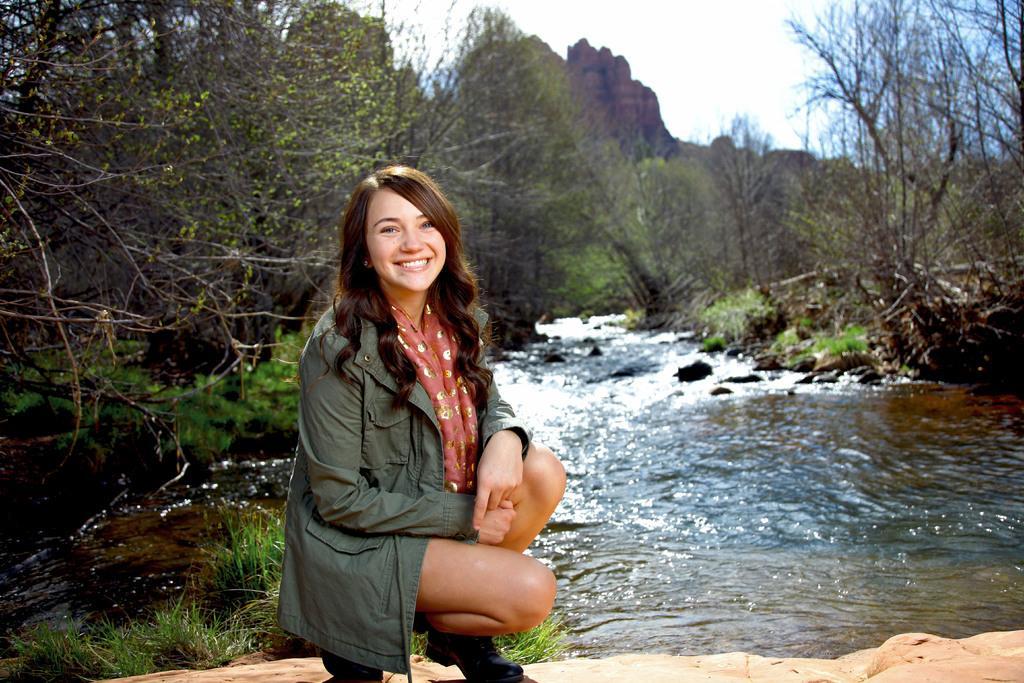How would you summarize this image in a sentence or two? This picture shows a woman with a smile on her face. She wore a coat and we see water flowing and we see trees and a hill and we see a cloudy sky. 